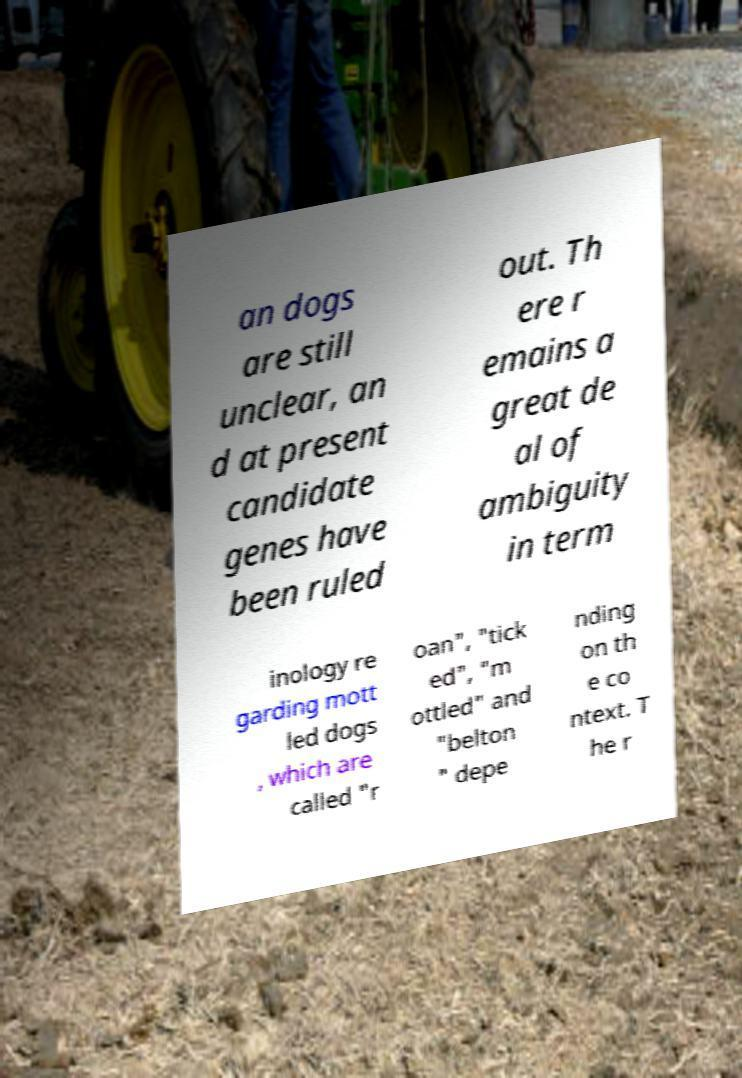I need the written content from this picture converted into text. Can you do that? an dogs are still unclear, an d at present candidate genes have been ruled out. Th ere r emains a great de al of ambiguity in term inology re garding mott led dogs , which are called "r oan", "tick ed", "m ottled" and "belton " depe nding on th e co ntext. T he r 